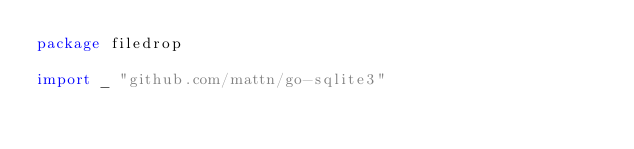<code> <loc_0><loc_0><loc_500><loc_500><_Go_>package filedrop

import _ "github.com/mattn/go-sqlite3"
</code> 